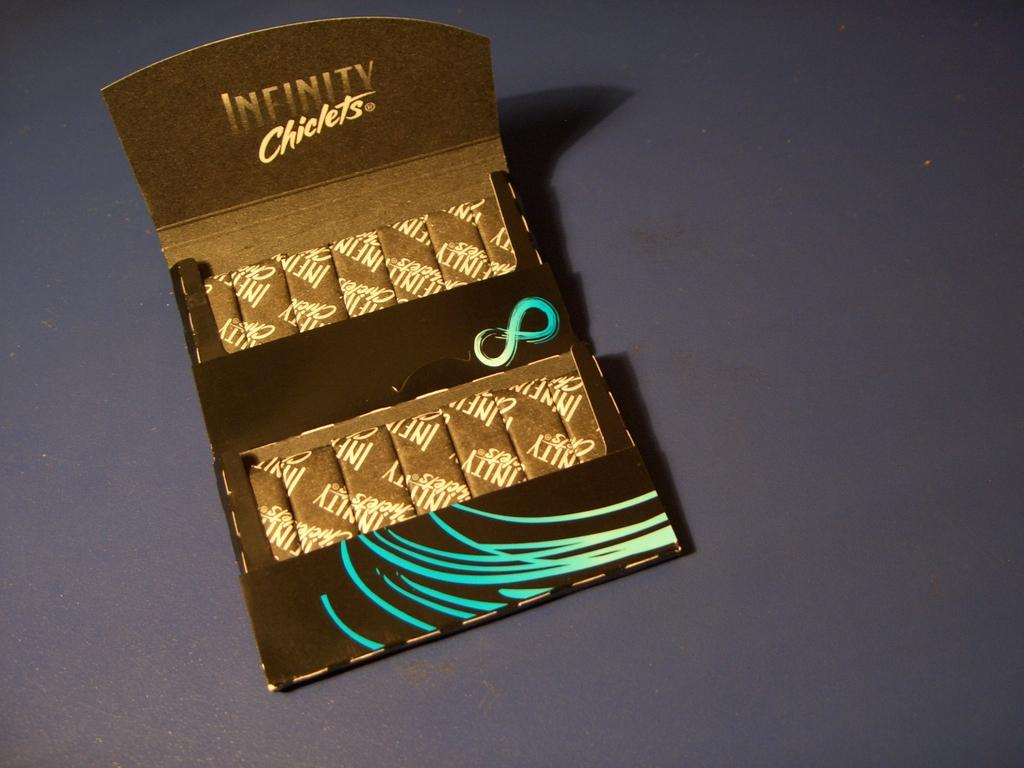<image>
Give a short and clear explanation of the subsequent image. Infinity Chiclets is the brand displayed on the inside of this packaging. 